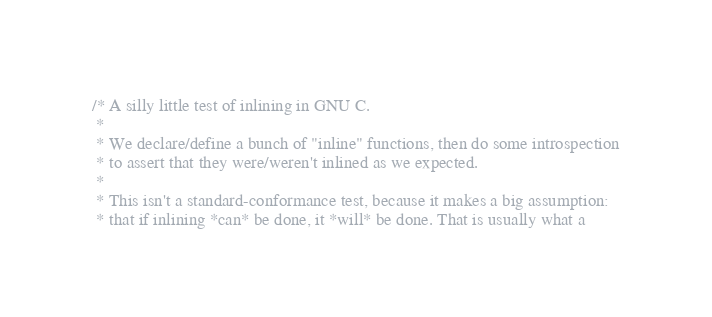Convert code to text. <code><loc_0><loc_0><loc_500><loc_500><_C_>/* A silly little test of inlining in GNU C.
 *
 * We declare/define a bunch of "inline" functions, then do some introspection
 * to assert that they were/weren't inlined as we expected.
 *
 * This isn't a standard-conformance test, because it makes a big assumption:
 * that if inlining *can* be done, it *will* be done. That is usually what a</code> 